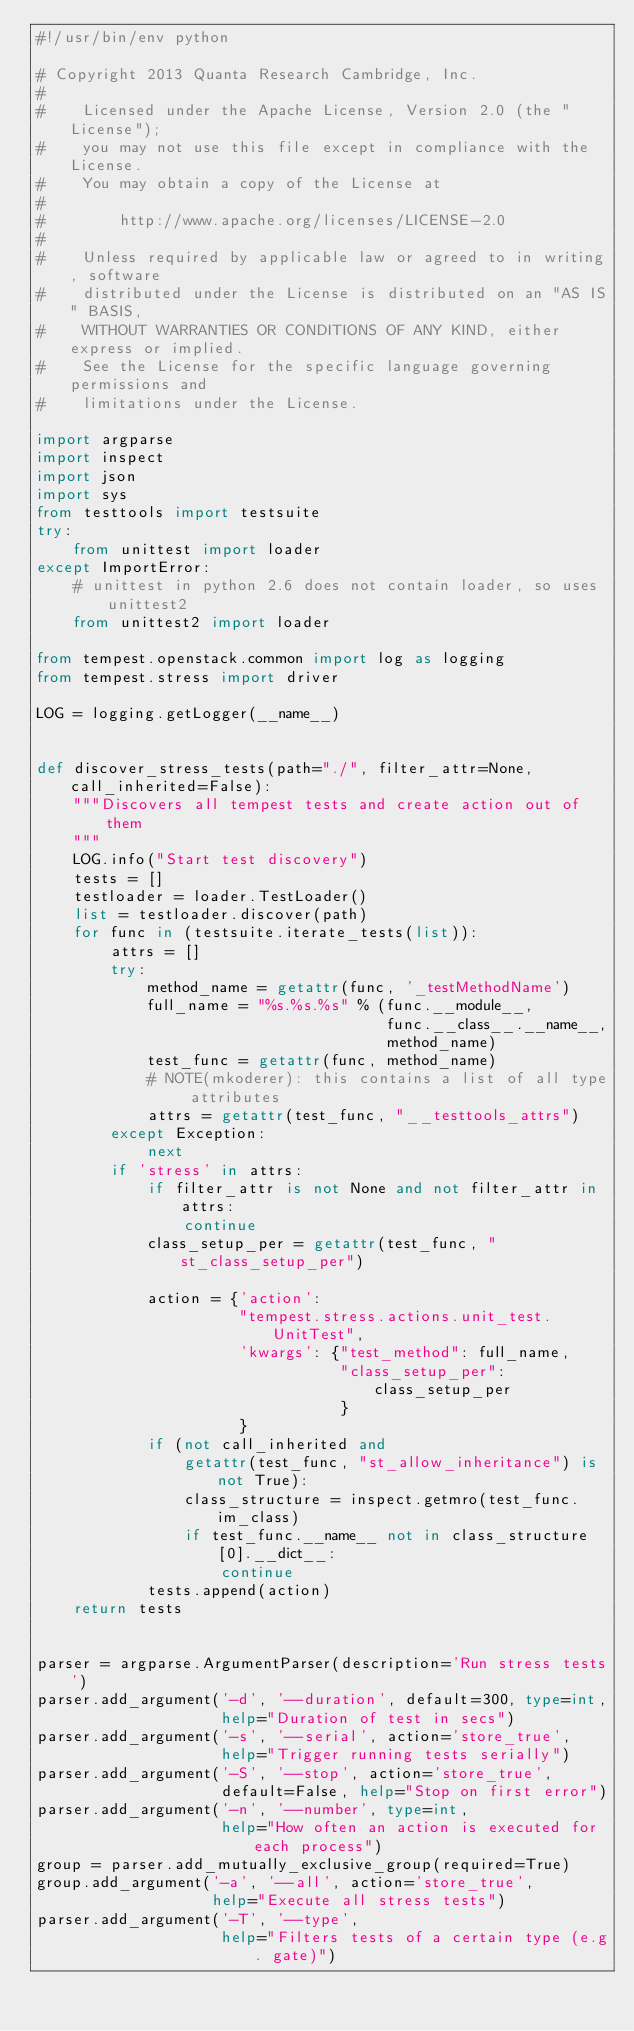<code> <loc_0><loc_0><loc_500><loc_500><_Python_>#!/usr/bin/env python

# Copyright 2013 Quanta Research Cambridge, Inc.
#
#    Licensed under the Apache License, Version 2.0 (the "License");
#    you may not use this file except in compliance with the License.
#    You may obtain a copy of the License at
#
#        http://www.apache.org/licenses/LICENSE-2.0
#
#    Unless required by applicable law or agreed to in writing, software
#    distributed under the License is distributed on an "AS IS" BASIS,
#    WITHOUT WARRANTIES OR CONDITIONS OF ANY KIND, either express or implied.
#    See the License for the specific language governing permissions and
#    limitations under the License.

import argparse
import inspect
import json
import sys
from testtools import testsuite
try:
    from unittest import loader
except ImportError:
    # unittest in python 2.6 does not contain loader, so uses unittest2
    from unittest2 import loader

from tempest.openstack.common import log as logging
from tempest.stress import driver

LOG = logging.getLogger(__name__)


def discover_stress_tests(path="./", filter_attr=None, call_inherited=False):
    """Discovers all tempest tests and create action out of them
    """
    LOG.info("Start test discovery")
    tests = []
    testloader = loader.TestLoader()
    list = testloader.discover(path)
    for func in (testsuite.iterate_tests(list)):
        attrs = []
        try:
            method_name = getattr(func, '_testMethodName')
            full_name = "%s.%s.%s" % (func.__module__,
                                      func.__class__.__name__,
                                      method_name)
            test_func = getattr(func, method_name)
            # NOTE(mkoderer): this contains a list of all type attributes
            attrs = getattr(test_func, "__testtools_attrs")
        except Exception:
            next
        if 'stress' in attrs:
            if filter_attr is not None and not filter_attr in attrs:
                continue
            class_setup_per = getattr(test_func, "st_class_setup_per")

            action = {'action':
                      "tempest.stress.actions.unit_test.UnitTest",
                      'kwargs': {"test_method": full_name,
                                 "class_setup_per": class_setup_per
                                 }
                      }
            if (not call_inherited and
                getattr(test_func, "st_allow_inheritance") is not True):
                class_structure = inspect.getmro(test_func.im_class)
                if test_func.__name__ not in class_structure[0].__dict__:
                    continue
            tests.append(action)
    return tests


parser = argparse.ArgumentParser(description='Run stress tests')
parser.add_argument('-d', '--duration', default=300, type=int,
                    help="Duration of test in secs")
parser.add_argument('-s', '--serial', action='store_true',
                    help="Trigger running tests serially")
parser.add_argument('-S', '--stop', action='store_true',
                    default=False, help="Stop on first error")
parser.add_argument('-n', '--number', type=int,
                    help="How often an action is executed for each process")
group = parser.add_mutually_exclusive_group(required=True)
group.add_argument('-a', '--all', action='store_true',
                   help="Execute all stress tests")
parser.add_argument('-T', '--type',
                    help="Filters tests of a certain type (e.g. gate)")</code> 